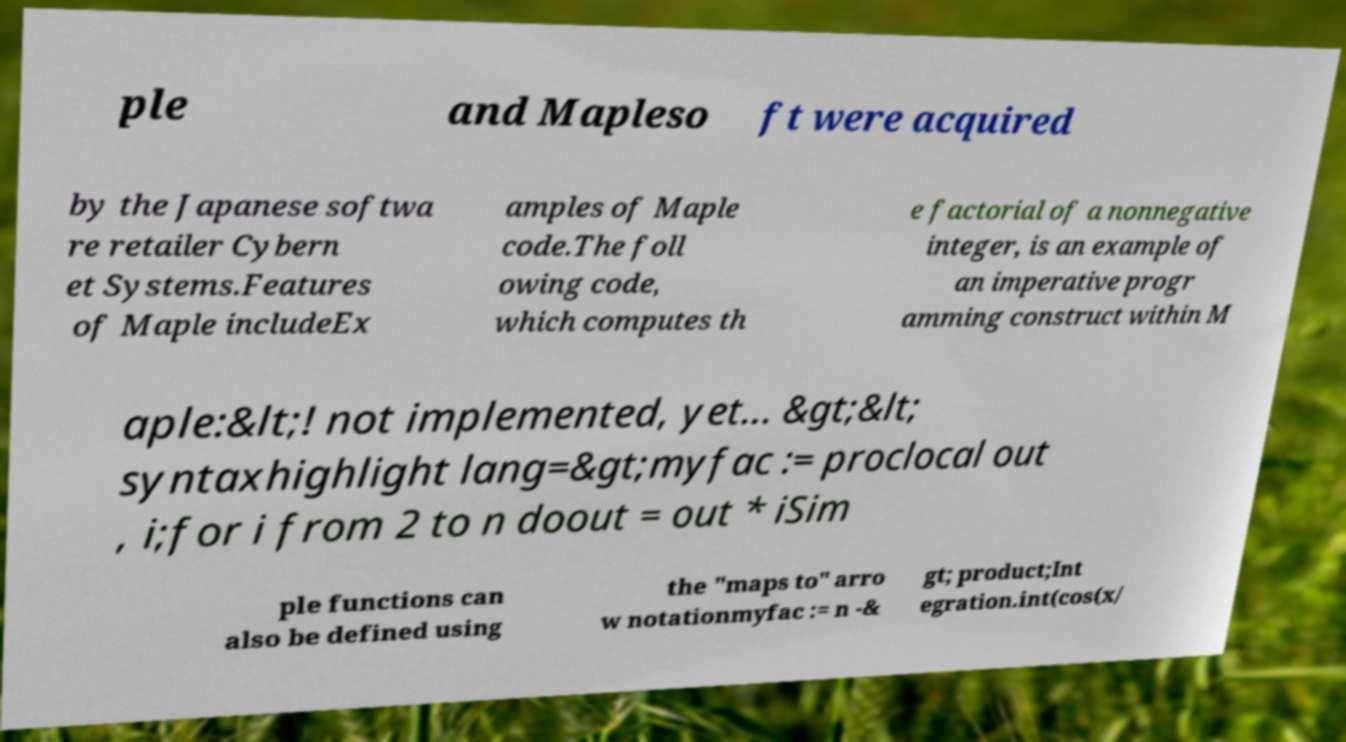Can you accurately transcribe the text from the provided image for me? ple and Mapleso ft were acquired by the Japanese softwa re retailer Cybern et Systems.Features of Maple includeEx amples of Maple code.The foll owing code, which computes th e factorial of a nonnegative integer, is an example of an imperative progr amming construct within M aple:&lt;! not implemented, yet... &gt;&lt; syntaxhighlight lang=&gt;myfac := proclocal out , i;for i from 2 to n doout = out * iSim ple functions can also be defined using the "maps to" arro w notationmyfac := n -& gt; product;Int egration.int(cos(x/ 